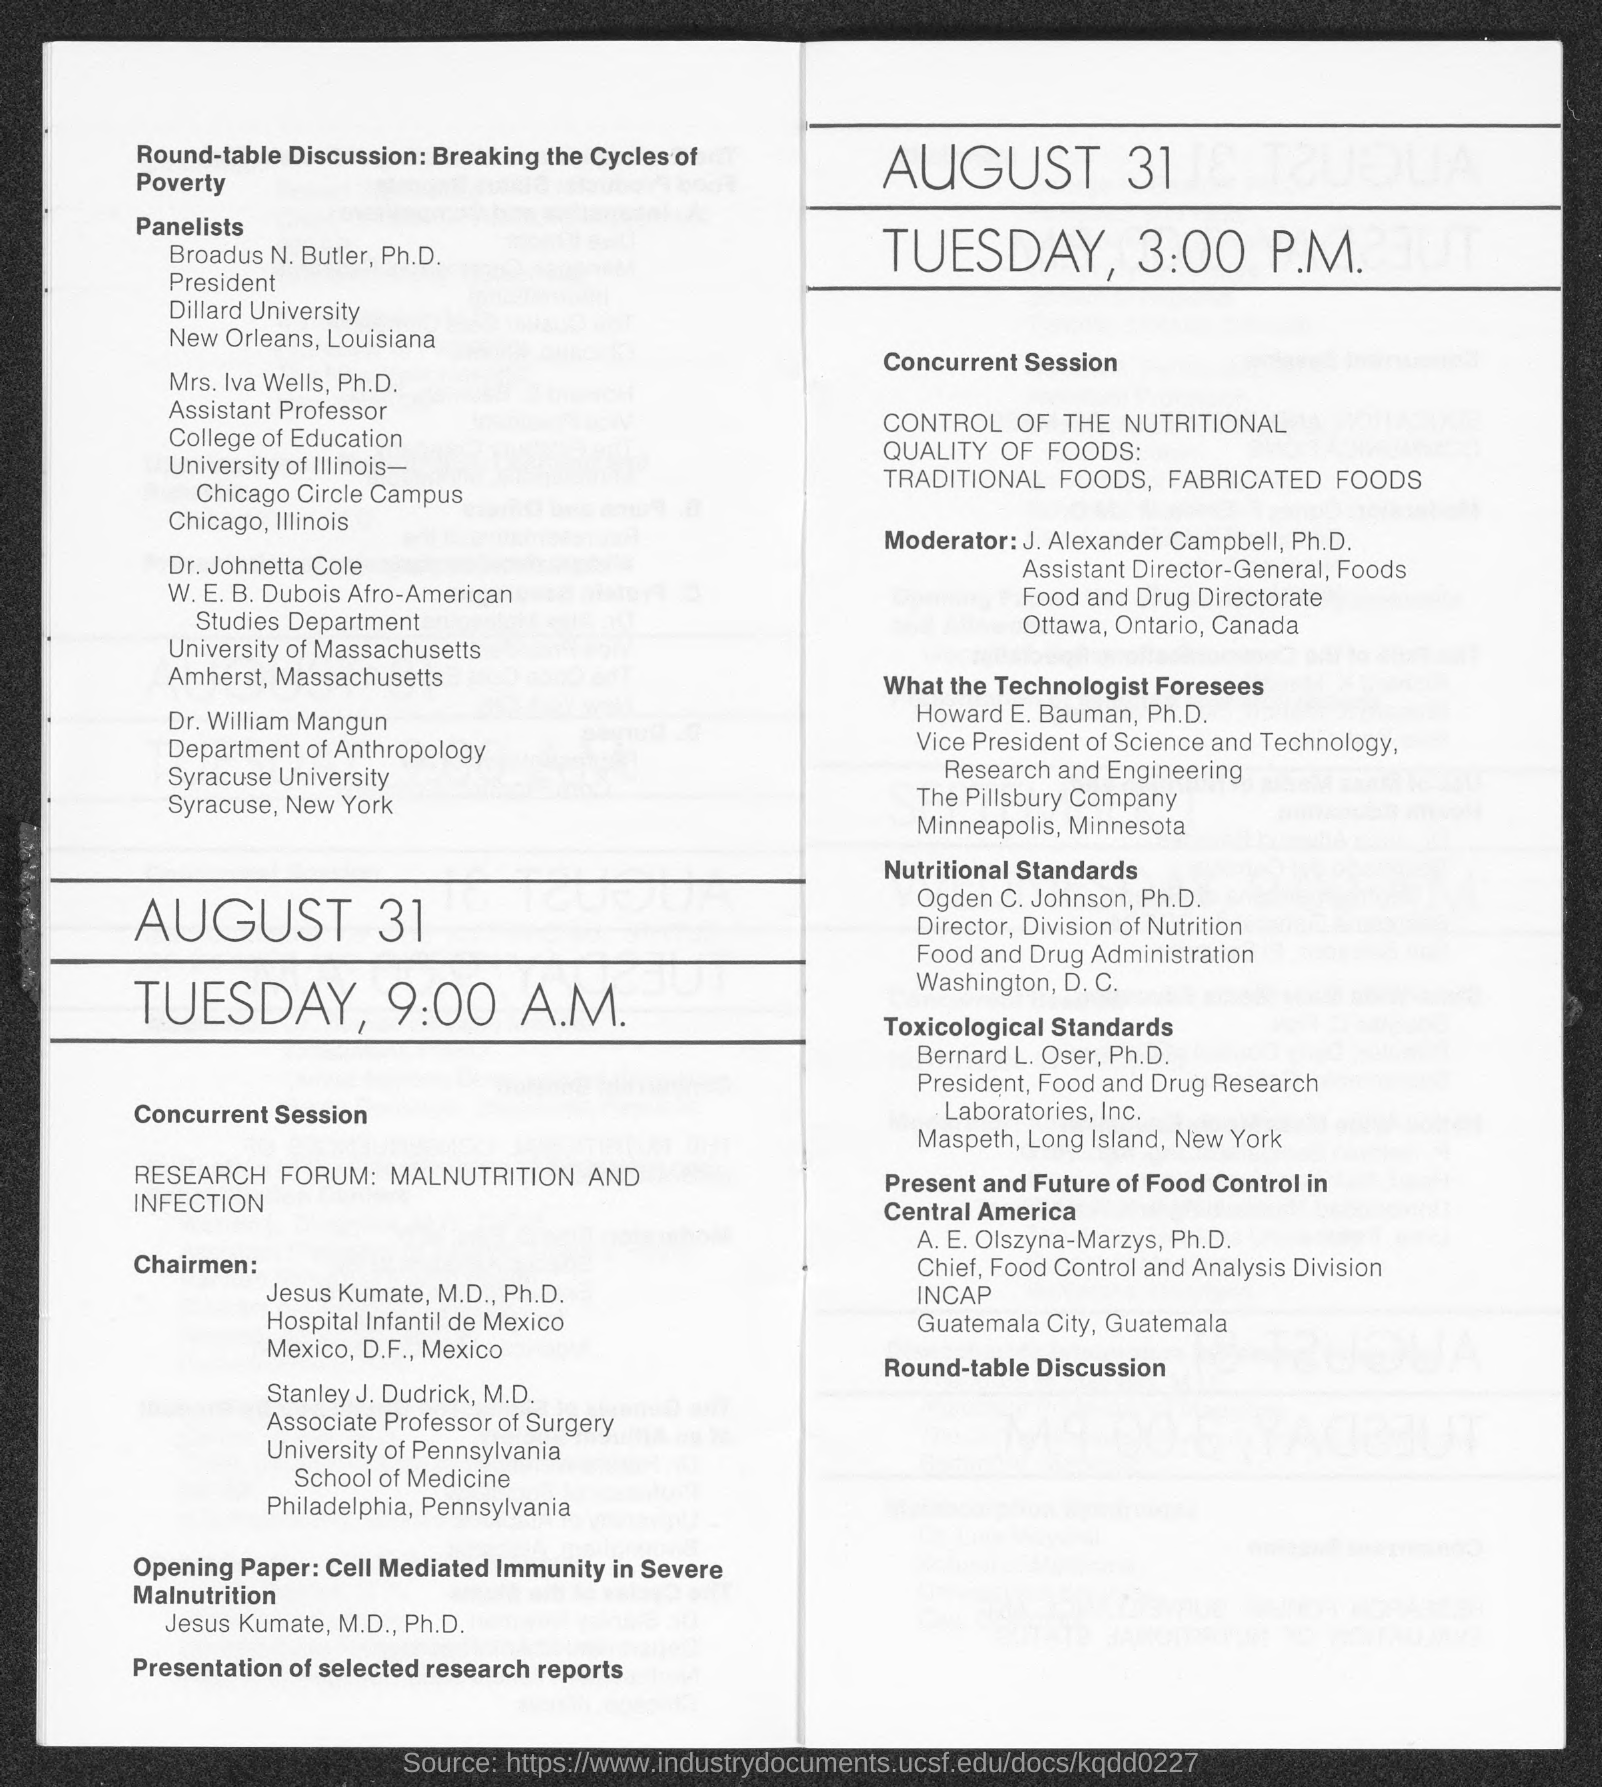What is the position of broadus n. buttler ?
Give a very brief answer. President. What is the position of mrs. iva wells ?
Your answer should be compact. Assistant professor. What is the position of stanley j. dudrick ?
Provide a succinct answer. Associate Professor of Surgery. What is the position of howard e. bauman ?
Keep it short and to the point. Vice President of science and Technology. What is the position of bernard l. oser, ph.d?
Make the answer very short. President. What is the position of ogden c. johnson ?
Give a very brief answer. Director. What is the position of a.e. olszyna- marzys ?
Provide a short and direct response. Chief. 